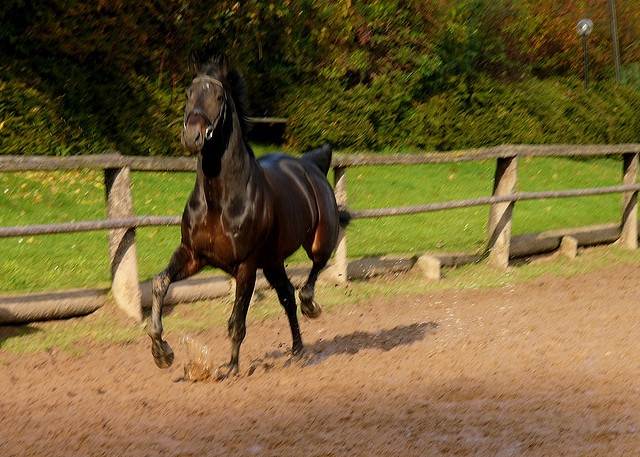Describe the objects in this image and their specific colors. I can see a horse in black, maroon, and gray tones in this image. 